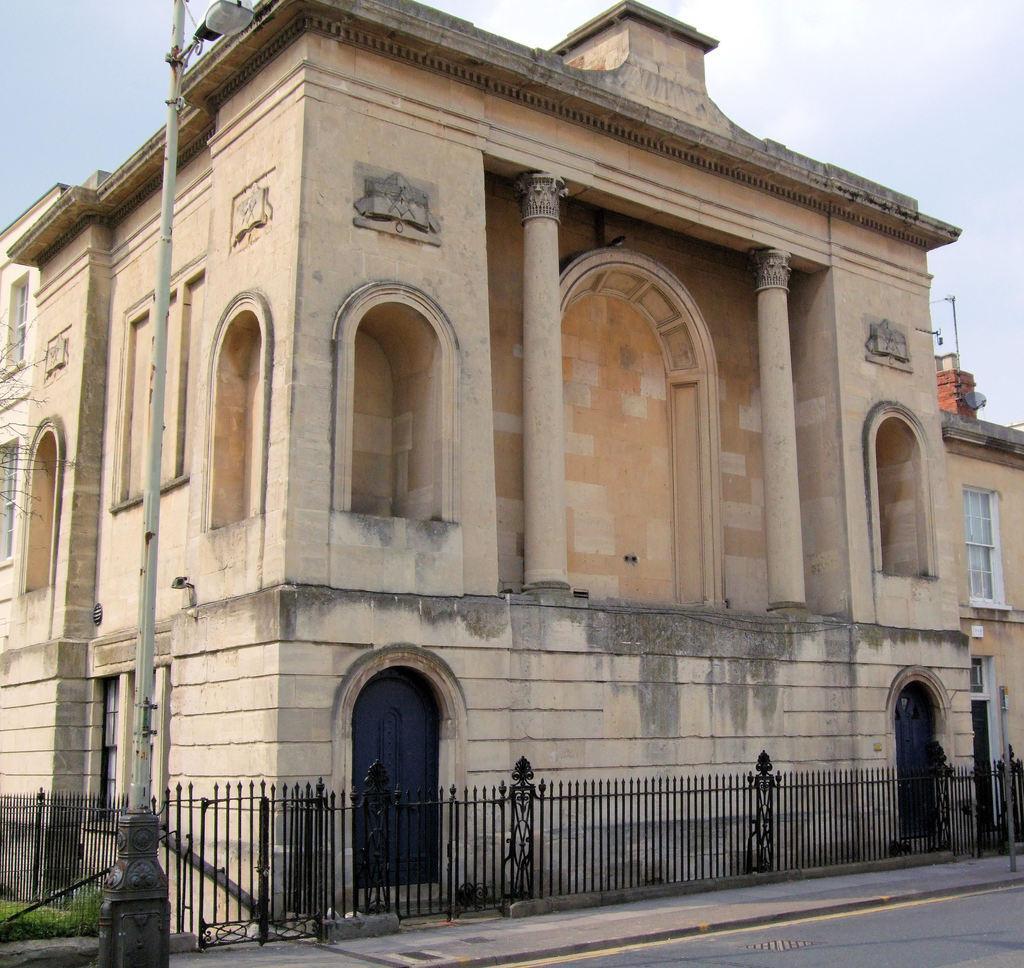How would you summarize this image in a sentence or two? In the image in the center there is a building,wall,fence,pillars,doors,poles,grass and road. In the background we can see the sky and clouds. 